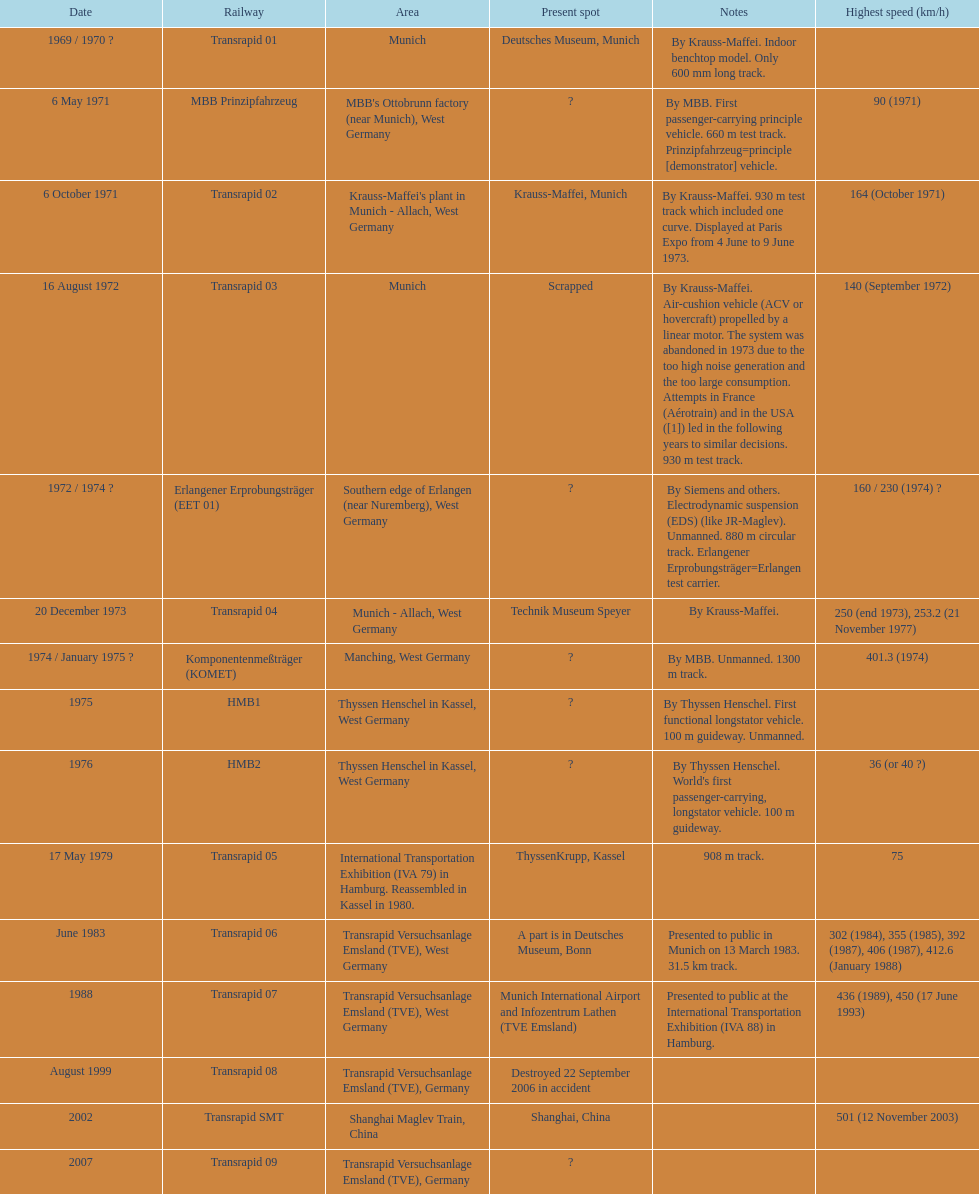What train was developed after the erlangener erprobungstrager? Transrapid 04. 